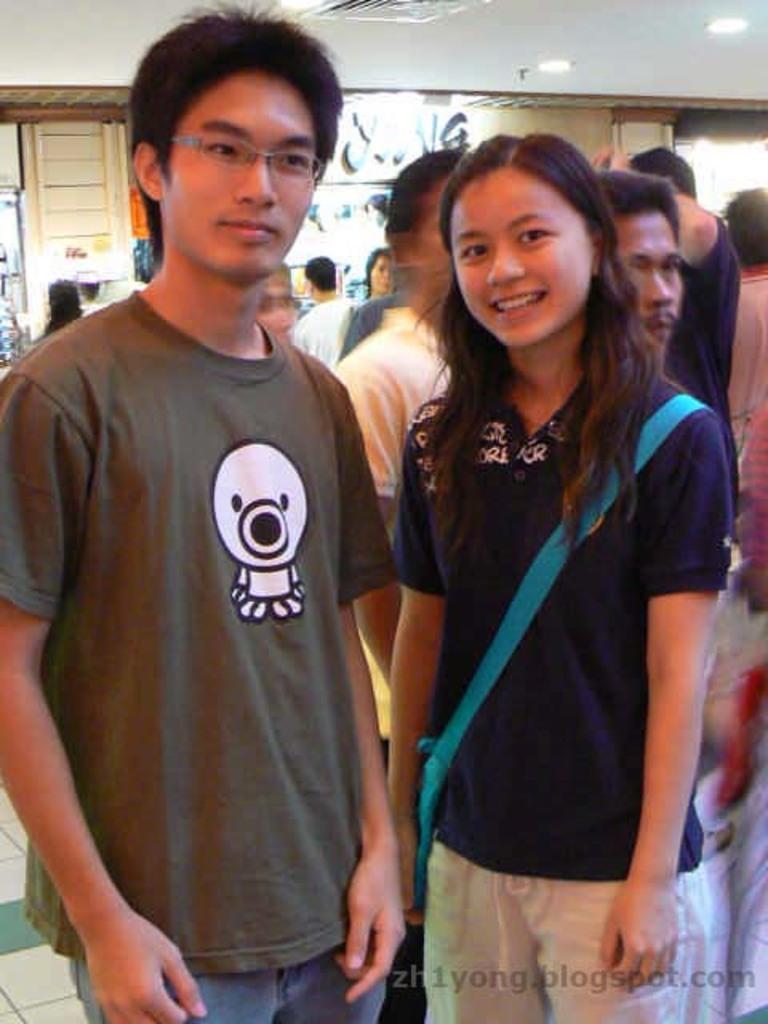Please provide a concise description of this image. This is the picture of a room. In the foreground there are two persons standing and smiling. At the back there are group of people and there are objects. At the top there are lights. In the bottom right there is a text. 